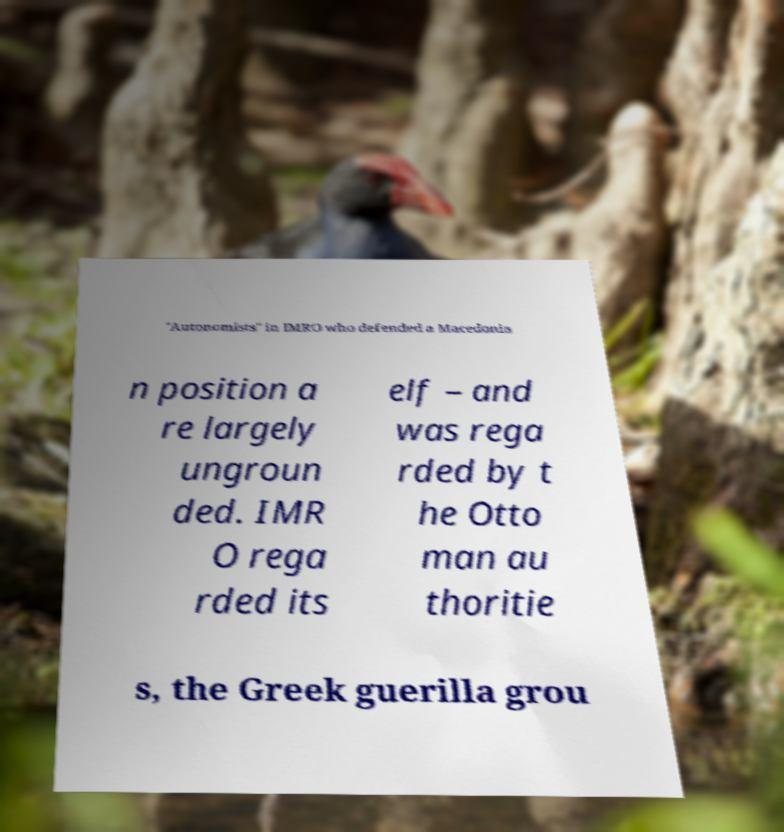For documentation purposes, I need the text within this image transcribed. Could you provide that? "Autonomists" in IMRO who defended a Macedonia n position a re largely ungroun ded. IMR O rega rded its elf – and was rega rded by t he Otto man au thoritie s, the Greek guerilla grou 